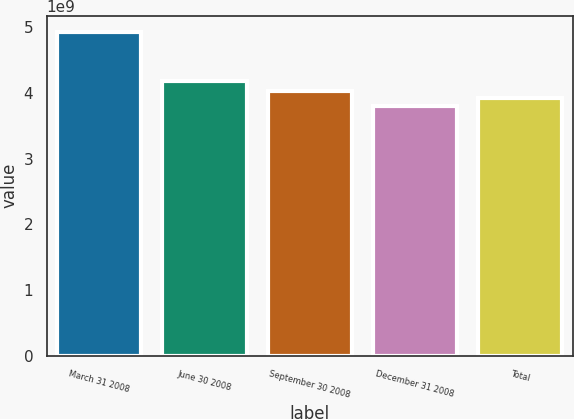<chart> <loc_0><loc_0><loc_500><loc_500><bar_chart><fcel>March 31 2008<fcel>June 30 2008<fcel>September 30 2008<fcel>December 31 2008<fcel>Total<nl><fcel>4.93185e+09<fcel>4.18184e+09<fcel>4.03426e+09<fcel>3.80986e+09<fcel>3.92206e+09<nl></chart> 